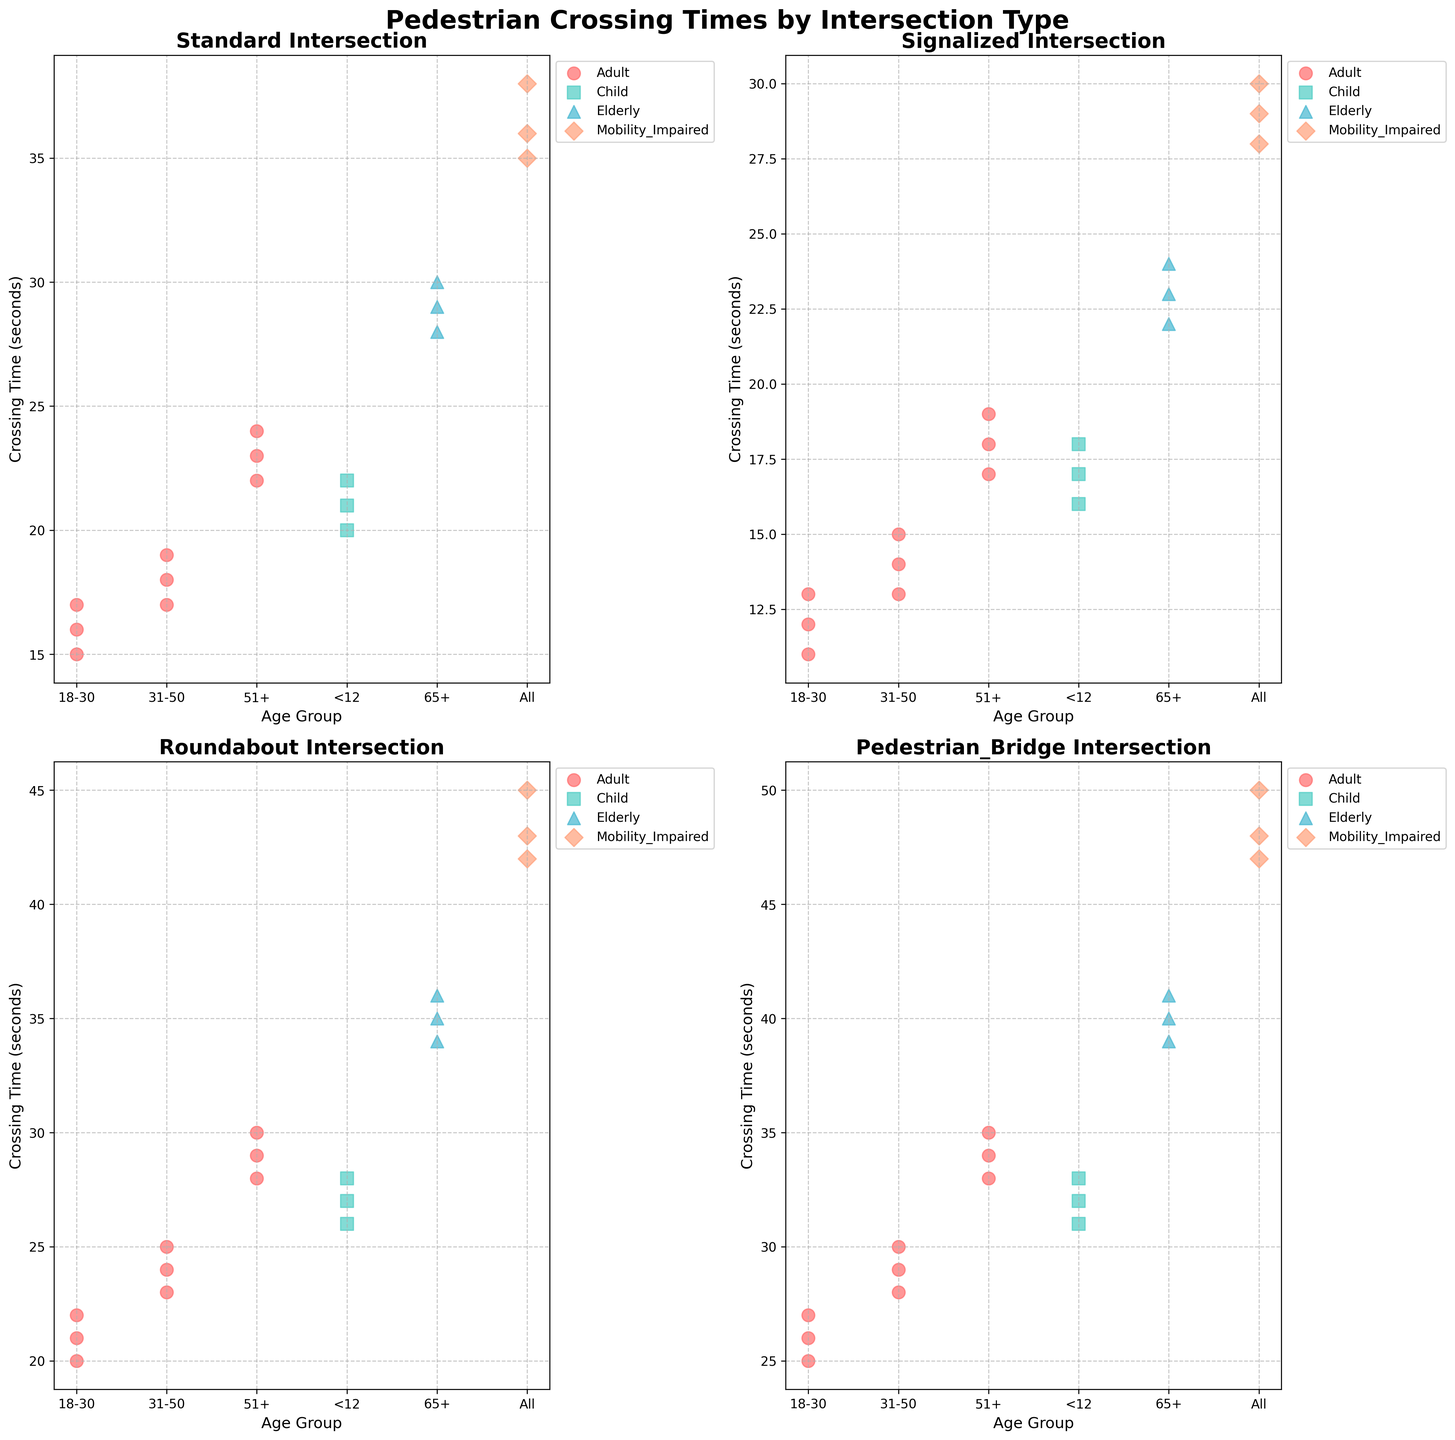What is the average crossing time for adults aged 18-30 at signalized intersections? Identify all the crossing times for adults aged 18-30 at signalized intersections: 12, 13, 11. Calculate the average: (12 + 13 + 11) / 3 = 12 seconds.
Answer: 12 seconds How does the crossing time for elderly pedestrians (65+) at pedestrian bridges compare to those at standard intersections? Compare the crossing times for elderly pedestrians at pedestrian bridges: 39, 41, 40, with the crossing times at standard intersections: 28, 30, 29. Observing the values, the average and individual crossing times are higher at pedestrian bridges.
Answer: Higher Which intersection type has the highest crossing time for mobility-impaired pedestrians? Observe the crossing times for mobility-impaired pedestrians across all intersection types. Values are: Standard (35, 38, 36), Signalized (28, 30, 29), Roundabout (42, 45, 43), Pedestrian Bridge (47, 50, 48). Identify the highest value (50) at pedestrian bridges.
Answer: Pedestrian Bridge Is there an age group of children (<12) that consistently has lower crossing times across intersection types? Look at the children's crossing times across all intersection types: Standard (20, 22, 21), Signalized (16, 18, 17), Roundabout (26, 28, 27), Pedestrian Bridge (31, 33, 32). Signalized intersections always have lower values compared to other intersection types.
Answer: Signalized Intersection What is the median crossing time for adults aged 31-50 at roundabouts? Identify the crossing times for adults aged 31-50 at roundabouts: 23, 25, 24. Order the values: 23, 24, 25. The middle value is 24, which is the median.
Answer: 24 seconds 